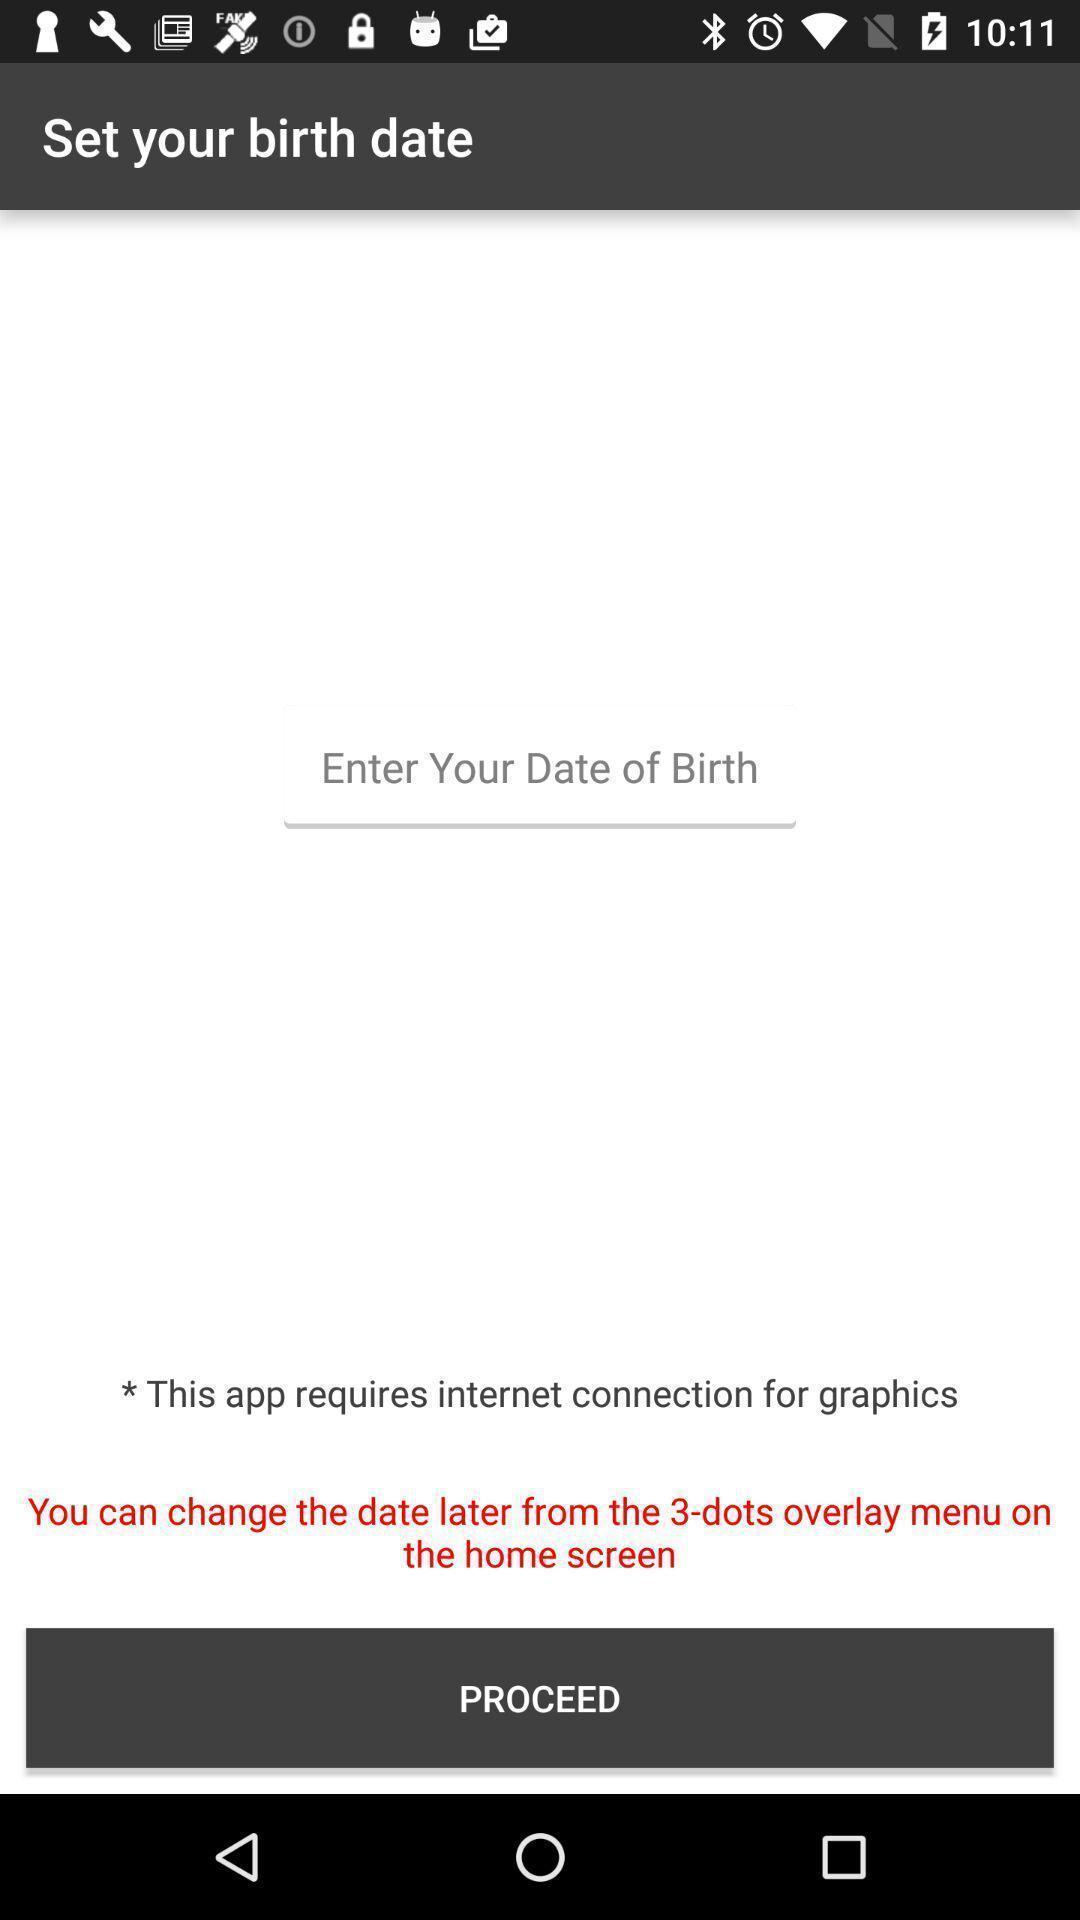Explain the elements present in this screenshot. Page displaying to enter date of birth in application. 